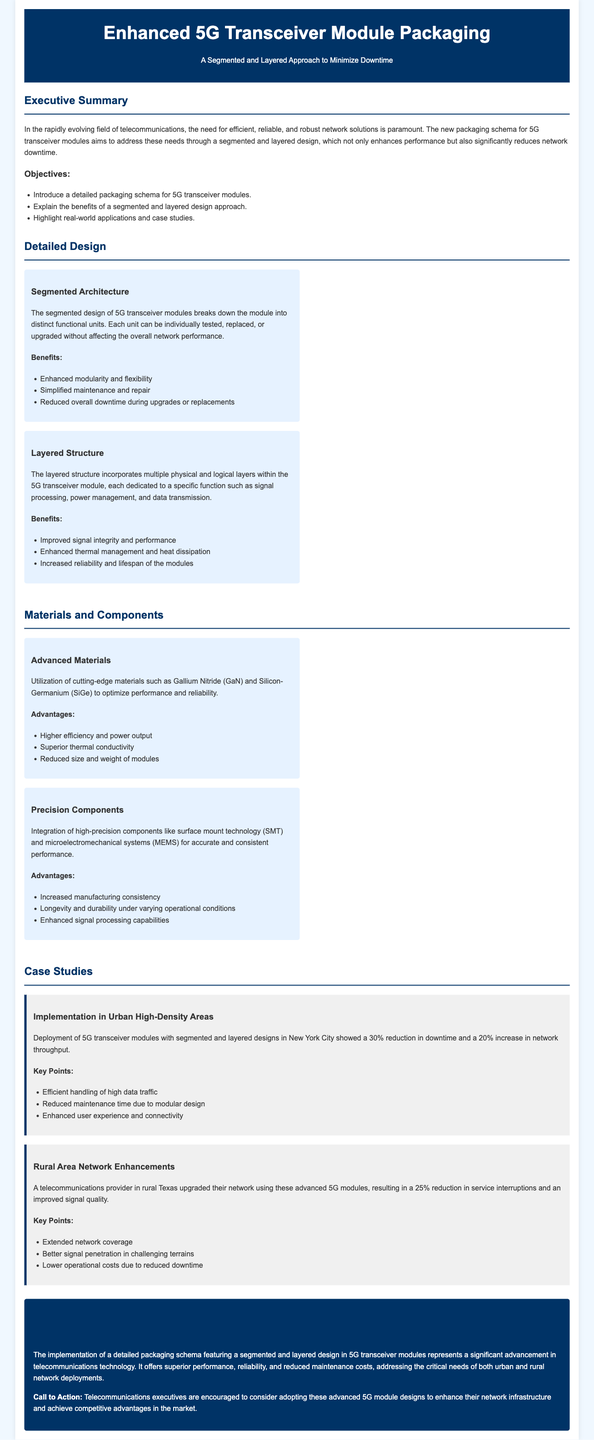What is the main objective of the packaging schema? The objective is to introduce a detailed packaging schema for 5G transceiver modules.
Answer: Introduce a detailed packaging schema for 5G transceiver modules What benefit does a segmented architecture provide? One of the benefits listed for a segmented architecture is simplified maintenance and repair.
Answer: Simplified maintenance and repair What advanced materials are utilized in the packaging? The document mentions utilization of Gallium Nitride (GaN) and Silicon-Germanium (SiGe).
Answer: Gallium Nitride and Silicon-Germanium What percentage reduction in downtime was observed in New York City? The case study indicated a 30% reduction in downtime.
Answer: 30% Which telecommunications provider is mentioned in the rural area case study? The case study does not specify the name of the telecommunications provider in rural Texas.
Answer: Not specified What is a key advantage of the layered structure? An advantage of the layered structure is improved signal integrity and performance.
Answer: Improved signal integrity and performance How much did service interruptions reduce in rural Texas? The rural Texas network upgrade led to a 25% reduction in service interruptions.
Answer: 25% What feature is highlighted under precision components? A highlighted feature of precision components is increased manufacturing consistency.
Answer: Increased manufacturing consistency 